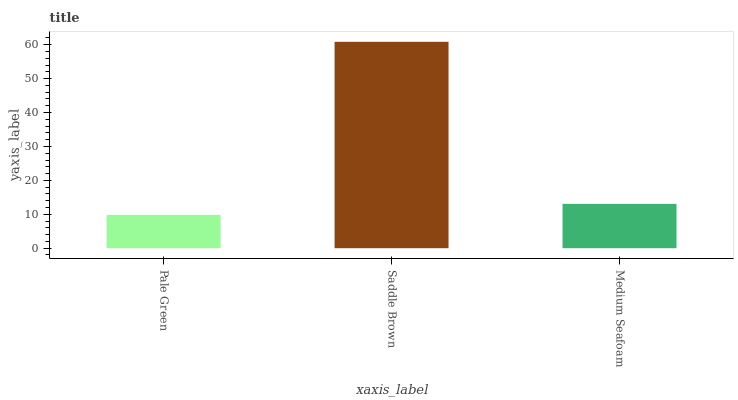Is Pale Green the minimum?
Answer yes or no. Yes. Is Saddle Brown the maximum?
Answer yes or no. Yes. Is Medium Seafoam the minimum?
Answer yes or no. No. Is Medium Seafoam the maximum?
Answer yes or no. No. Is Saddle Brown greater than Medium Seafoam?
Answer yes or no. Yes. Is Medium Seafoam less than Saddle Brown?
Answer yes or no. Yes. Is Medium Seafoam greater than Saddle Brown?
Answer yes or no. No. Is Saddle Brown less than Medium Seafoam?
Answer yes or no. No. Is Medium Seafoam the high median?
Answer yes or no. Yes. Is Medium Seafoam the low median?
Answer yes or no. Yes. Is Saddle Brown the high median?
Answer yes or no. No. Is Saddle Brown the low median?
Answer yes or no. No. 